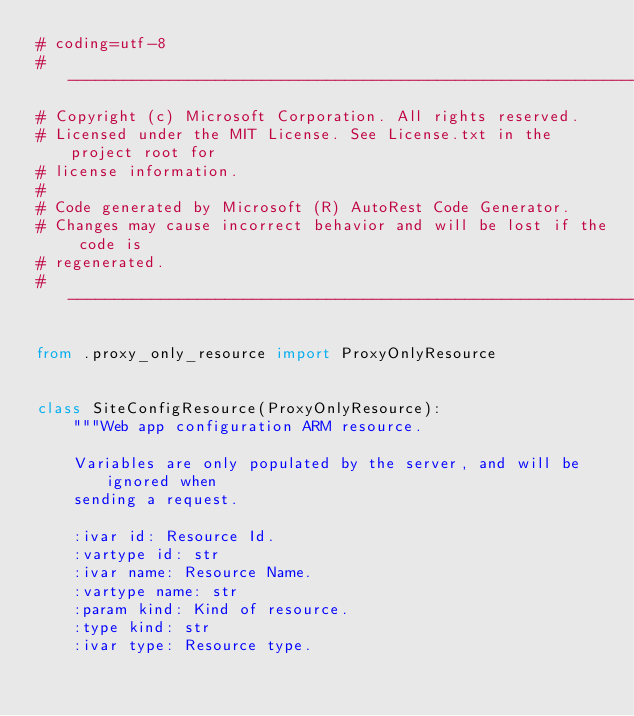Convert code to text. <code><loc_0><loc_0><loc_500><loc_500><_Python_># coding=utf-8
# --------------------------------------------------------------------------
# Copyright (c) Microsoft Corporation. All rights reserved.
# Licensed under the MIT License. See License.txt in the project root for
# license information.
#
# Code generated by Microsoft (R) AutoRest Code Generator.
# Changes may cause incorrect behavior and will be lost if the code is
# regenerated.
# --------------------------------------------------------------------------

from .proxy_only_resource import ProxyOnlyResource


class SiteConfigResource(ProxyOnlyResource):
    """Web app configuration ARM resource.

    Variables are only populated by the server, and will be ignored when
    sending a request.

    :ivar id: Resource Id.
    :vartype id: str
    :ivar name: Resource Name.
    :vartype name: str
    :param kind: Kind of resource.
    :type kind: str
    :ivar type: Resource type.</code> 